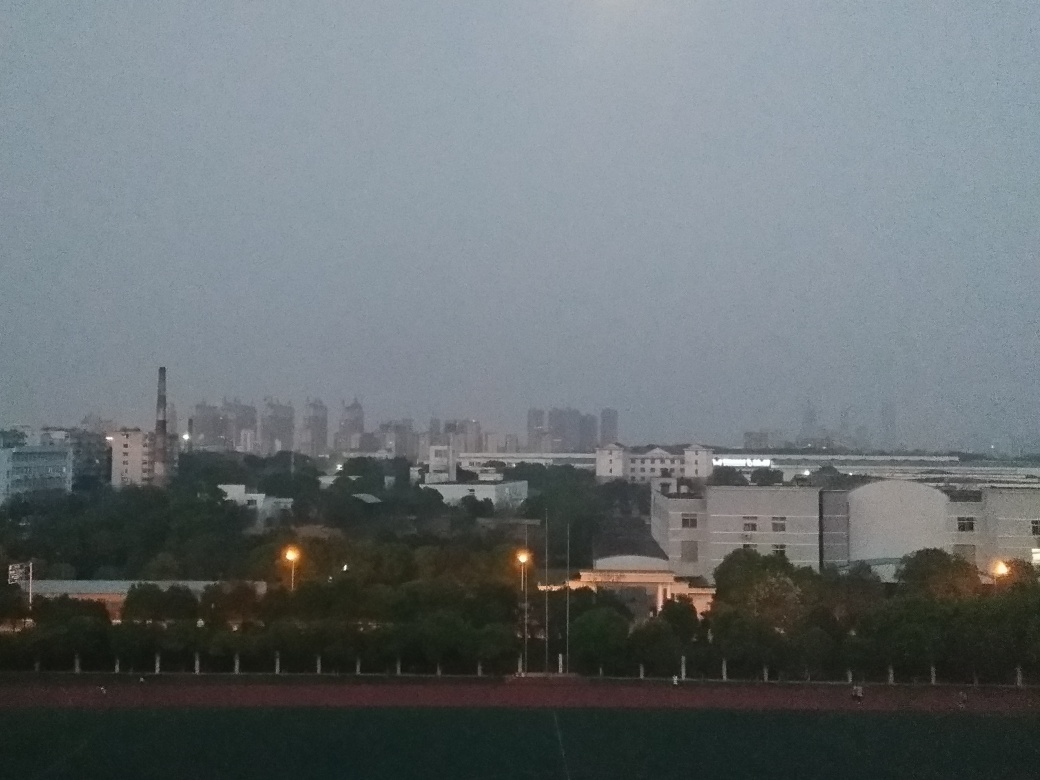Are there any noise points in the image? Although the image exhibits a relatively low level of visual noise due to the dim lighting conditions, which could introduce graininess, no pronounced noise points, such as unexpected bright spots or distortions, are immediately apparent. 